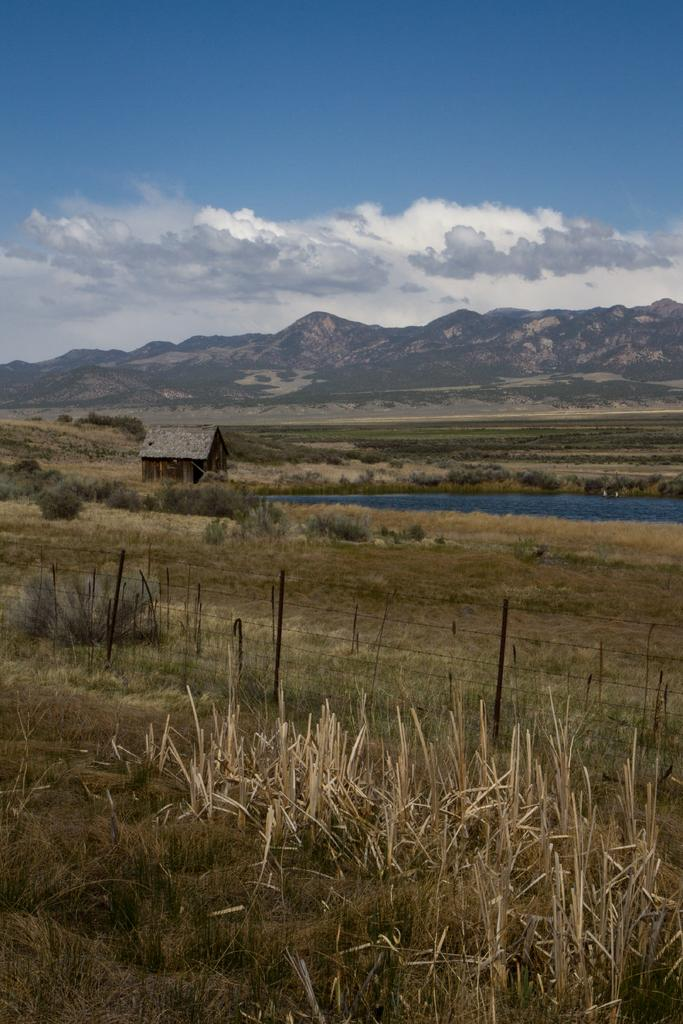What type of vegetation can be seen in the image? There is dry grass in the image. What kind of barrier is present in the image? There is a wired fence in the image. What type of building is visible in the image? There is a wooden house in the image. What other plants can be seen in the image besides dry grass? There are shrubs in the image. What natural feature can be seen in the image? There is water visible in the image. What geographical feature is present in the image? There are hills in the image. What is the color of the sky in the image? The sky is blue with clouds in the background. Can you tell me how many toes are visible on the wooden house in the image? There are no toes present in the image, as the wooden house is an inanimate object and does not have body parts. What type of slope is visible on the shrubs in the image? There is no slope visible on the shrubs in the image; they are simply plants growing in the area. 